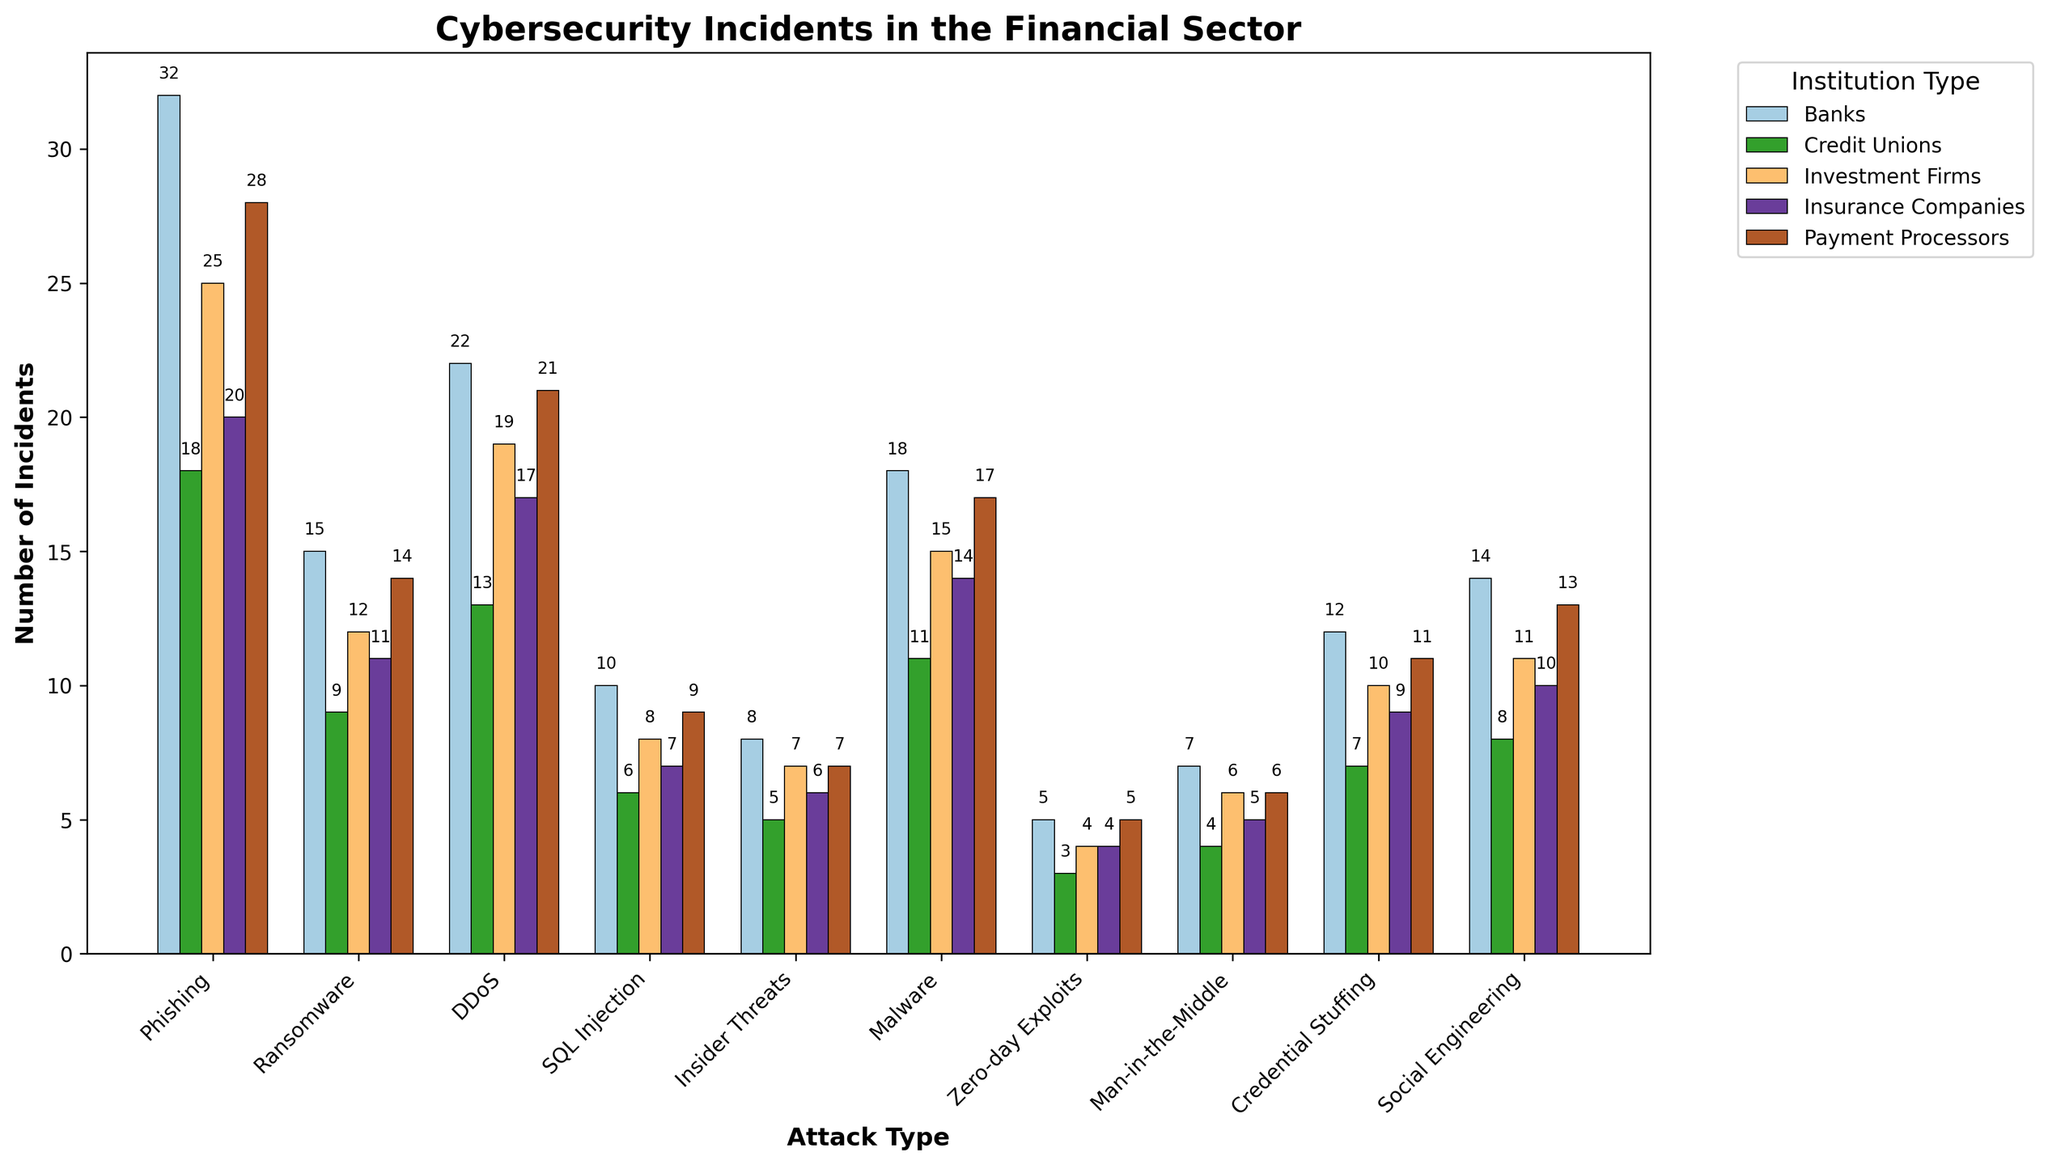Which institution type experienced the most Phishing attacks? The height of the bars represents the number of incidents. The highest bar in the Phishing category corresponds to Banks with 32 incidents.
Answer: Banks Which attack type had the least number of incidents across all institutions? Zero-day Exploits have the smallest bars across all institutions with a maximum value of 5 incidents across all institution types.
Answer: Zero-day Exploits What is the difference in the number of DDoS incidents between Banks and Insurance Companies? The bar for Banks under the DDoS category is 22, and the bar for Insurance Companies is 17. The difference is 22 - 17.
Answer: 5 What attack type resulted in the highest number of incidents for Payment Processors? The tallest bar under the category of Payment Processors is for Phishing, with 28 incidents.
Answer: Phishing Which attack type has a higher count in Credit Unions, Malware or Social Engineering? The height of the bars for Credit Unions under Malware and Social Engineering categories indicates that Malware (11) has a higher count than Social Engineering (8).
Answer: Malware What is the total number of Ransomware incidents across all institution types? Sum the values for Ransomware incidents across all institutions: 15 (Banks) + 9 (Credit Unions) + 12 (Investment Firms) + 11 (Insurance Companies) + 14 (Payment Processors) = 61.
Answer: 61 Which institution experienced fewer Insider Threat incidents, Banks or Insurance Companies? By comparing the heights of the bars under Insider Threats, Banks experienced 8 incidents while Insurance Companies experienced 6. Therefore, Insurance Companies had fewer incidents.
Answer: Insurance Companies What is the average number of Phishing incidents across all institutions? The number of Phishing incidents across institutions are 32 (Banks), 18 (Credit Unions), 25 (Investment Firms), 20 (Insurance Companies), and 28 (Payment Processors). The average is (32 + 18 + 25 + 20 + 28) / 5 = 24.6.
Answer: 24.6 Which attack had the greatest discrepancy in the number of incidents between Banks and Credit Unions? Inspect each attack type's bars for Banks and Credit Unions and find the difference: Phishing = 32 - 18 = 14, Ransomware = 15 - 9 = 6, DDoS = 22 - 13 = 9, SQL Injection = 10 - 6 = 4, Insider Threats = 8 - 5 = 3, Malware = 18 - 11 = 7, Zero-day Exploits = 5 - 3 = 2, Man-in-the-Middle = 7 - 4 = 3, Credential Stuffing = 12 - 7 = 5, Social Engineering = 14 - 8 = 6. The greatest discrepancy is for Phishing.
Answer: Phishing 